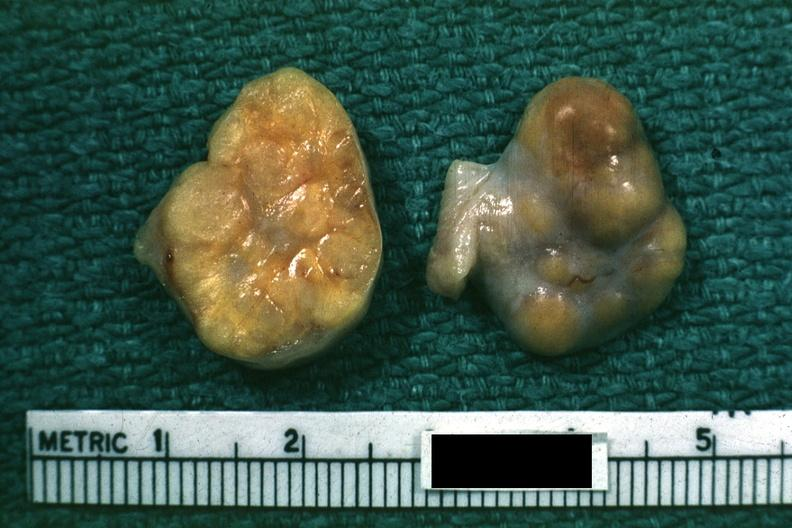s female reproductive present?
Answer the question using a single word or phrase. Yes 